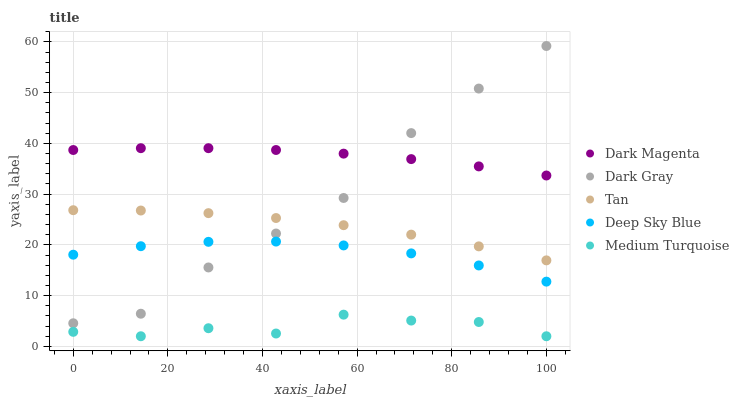Does Medium Turquoise have the minimum area under the curve?
Answer yes or no. Yes. Does Dark Magenta have the maximum area under the curve?
Answer yes or no. Yes. Does Tan have the minimum area under the curve?
Answer yes or no. No. Does Tan have the maximum area under the curve?
Answer yes or no. No. Is Dark Magenta the smoothest?
Answer yes or no. Yes. Is Dark Gray the roughest?
Answer yes or no. Yes. Is Tan the smoothest?
Answer yes or no. No. Is Tan the roughest?
Answer yes or no. No. Does Medium Turquoise have the lowest value?
Answer yes or no. Yes. Does Tan have the lowest value?
Answer yes or no. No. Does Dark Gray have the highest value?
Answer yes or no. Yes. Does Tan have the highest value?
Answer yes or no. No. Is Deep Sky Blue less than Dark Magenta?
Answer yes or no. Yes. Is Dark Gray greater than Medium Turquoise?
Answer yes or no. Yes. Does Dark Magenta intersect Dark Gray?
Answer yes or no. Yes. Is Dark Magenta less than Dark Gray?
Answer yes or no. No. Is Dark Magenta greater than Dark Gray?
Answer yes or no. No. Does Deep Sky Blue intersect Dark Magenta?
Answer yes or no. No. 